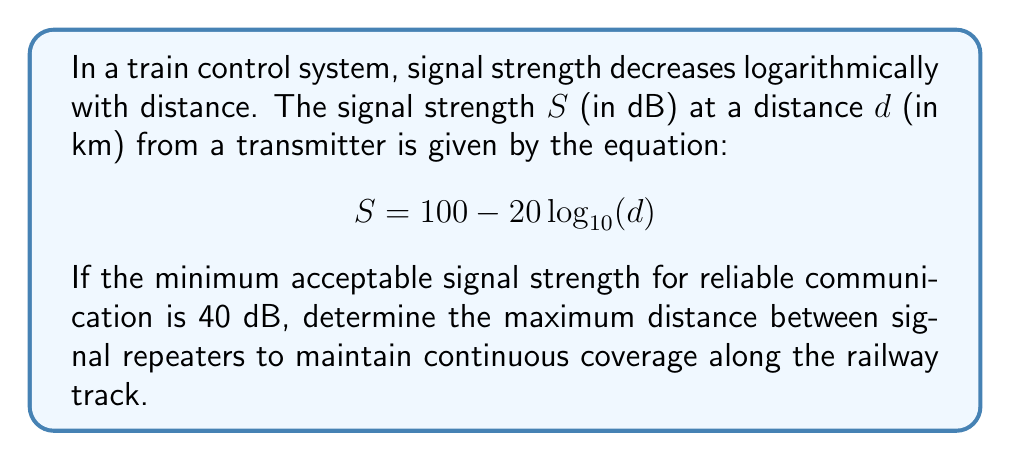Can you solve this math problem? To solve this problem, we need to find the distance at which the signal strength drops to 40 dB. We can do this by substituting the known values into the given equation and solving for $d$.

1) Start with the given equation:
   $$S = 100 - 20\log_{10}(d)$$

2) Substitute the minimum acceptable signal strength (40 dB) for $S$:
   $$40 = 100 - 20\log_{10}(d)$$

3) Subtract 100 from both sides:
   $$-60 = -20\log_{10}(d)$$

4) Divide both sides by -20:
   $$3 = \log_{10}(d)$$

5) Apply the inverse function (10 to the power) to both sides:
   $$10^3 = d$$

6) Evaluate:
   $$1000 = d$$

Therefore, the maximum distance between signal repeaters is 1000 km.

To maintain continuous coverage, repeaters should be placed slightly closer than this maximum distance, accounting for potential signal variations due to terrain and other factors.
Answer: 1000 km 